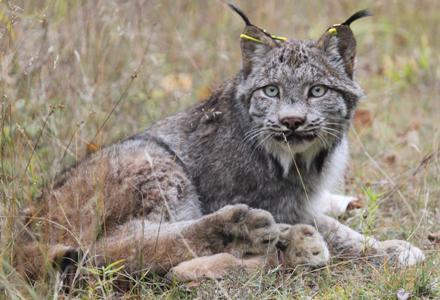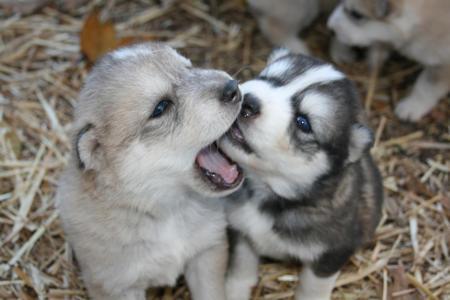The first image is the image on the left, the second image is the image on the right. Examine the images to the left and right. Is the description "There is a wolf in the water." accurate? Answer yes or no. No. The first image is the image on the left, the second image is the image on the right. Evaluate the accuracy of this statement regarding the images: "In the right image, one wolf has its open jaw around part of a wolf pup.". Is it true? Answer yes or no. Yes. 